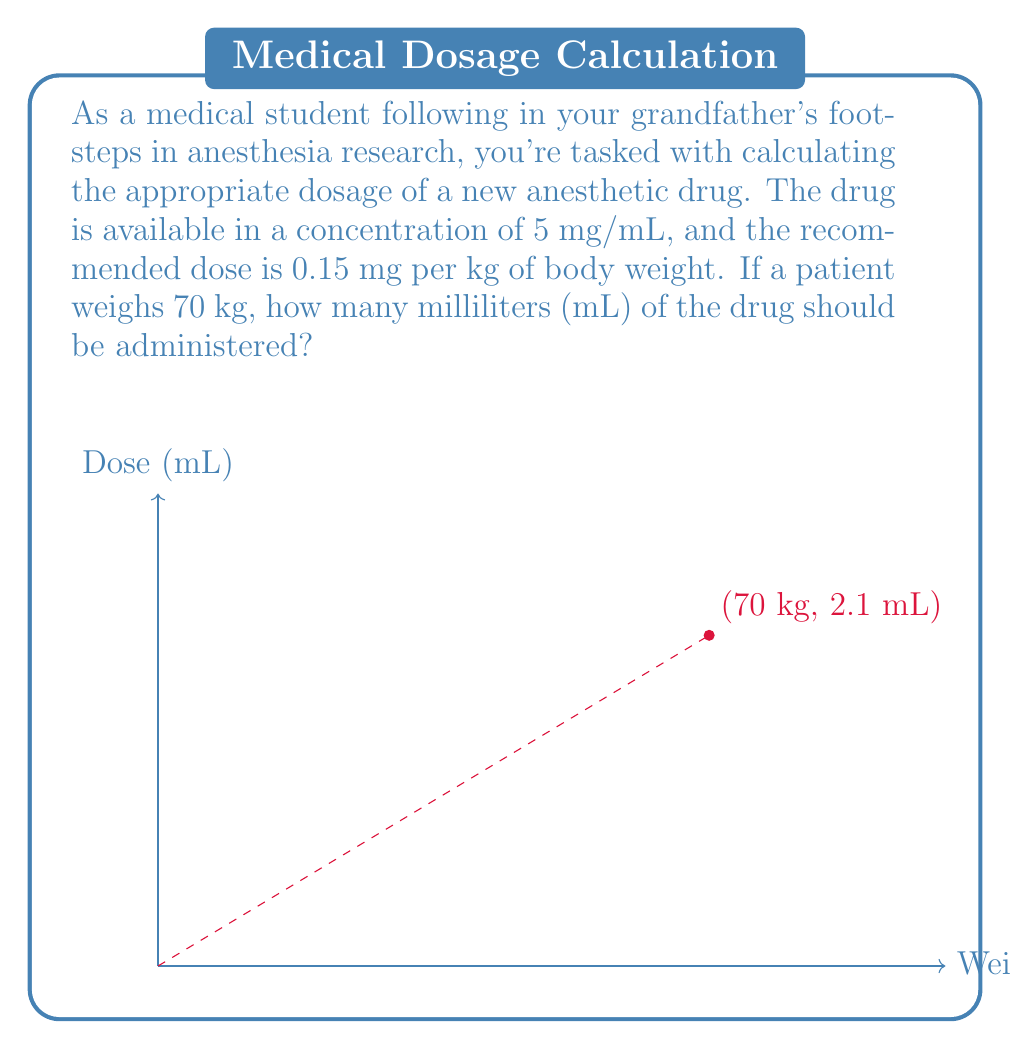Could you help me with this problem? Let's approach this step-by-step:

1) First, calculate the total dose needed for the patient:
   $$\text{Total dose} = \text{Dose per kg} \times \text{Patient weight}$$
   $$\text{Total dose} = 0.15 \text{ mg/kg} \times 70 \text{ kg} = 10.5 \text{ mg}$$

2) Now, we need to convert this dose to milliliters. We know the concentration is 5 mg/mL.
   Let's set up a rational expression:
   $$\frac{\text{Dose in mg}}{\text{Volume in mL}} = \frac{5 \text{ mg}}{1 \text{ mL}}$$

3) Cross multiply:
   $$10.5 \times 1 = 5 \times \text{Volume}$$

4) Solve for Volume:
   $$\text{Volume} = \frac{10.5}{5} = 2.1 \text{ mL}$$

Therefore, 2.1 mL of the drug should be administered to the patient.
Answer: 2.1 mL 